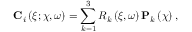Convert formula to latex. <formula><loc_0><loc_0><loc_500><loc_500>C _ { i } \left ( \xi ; \boldsymbol \chi , \omega \right ) = \sum _ { k = 1 } ^ { 3 } R _ { k } \left ( \xi , \omega \right ) P _ { k } \left ( \boldsymbol \chi \right ) ,</formula> 